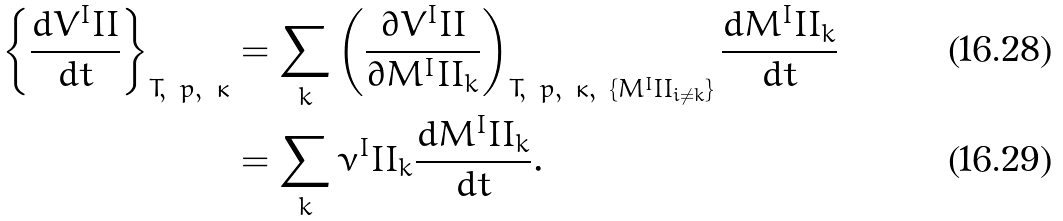Convert formula to latex. <formula><loc_0><loc_0><loc_500><loc_500>\left \{ \frac { d V ^ { I } I I } { d t } \right \} _ { T , \ p , \ \kappa } & = \sum _ { k } \left ( \frac { \partial V ^ { I } I I } { \partial M ^ { I } I I _ { k } } \right ) _ { T , \ p , \ \kappa , \ \{ M ^ { I } I I _ { i \neq k } \} } \frac { d M ^ { I } I I _ { k } } { d t } \\ & = \sum _ { k } \nu ^ { I } I I _ { k } \frac { d M ^ { I } I I _ { k } } { d t } .</formula> 